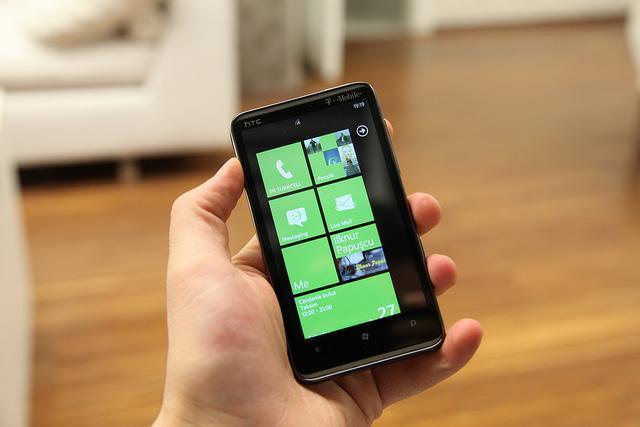How many people are visible?
Give a very brief answer. 1. 